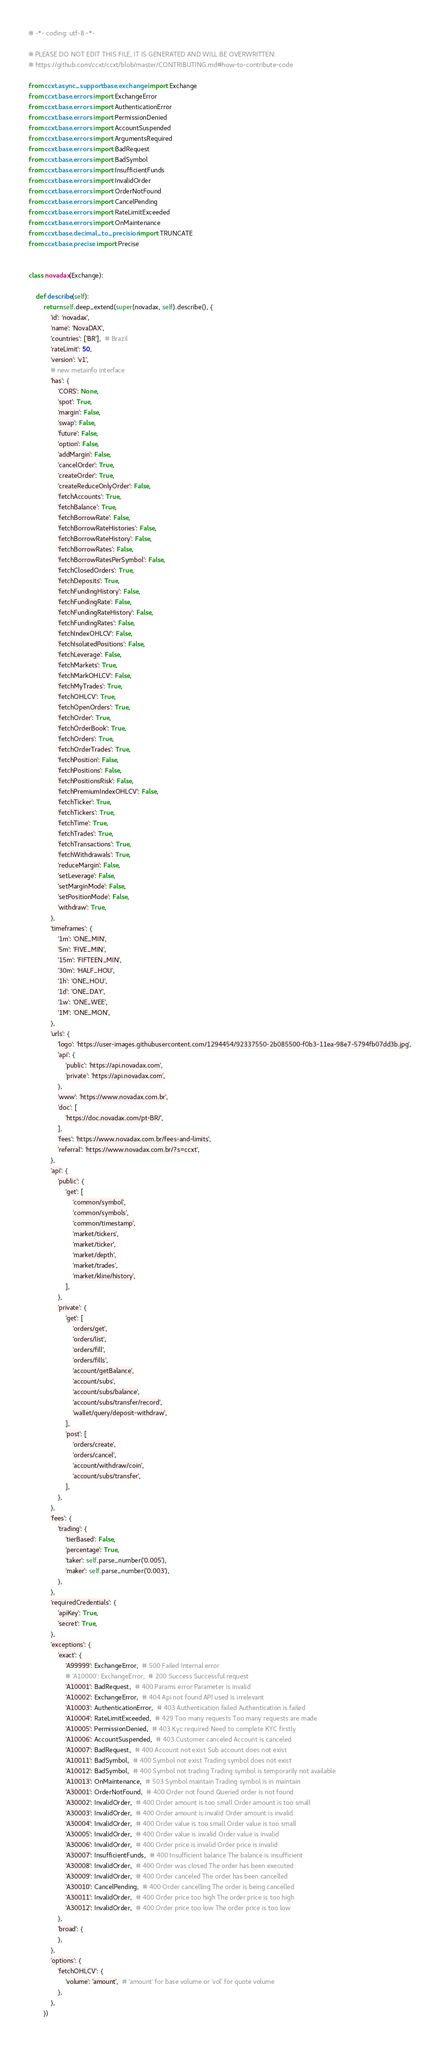Convert code to text. <code><loc_0><loc_0><loc_500><loc_500><_Python_># -*- coding: utf-8 -*-

# PLEASE DO NOT EDIT THIS FILE, IT IS GENERATED AND WILL BE OVERWRITTEN:
# https://github.com/ccxt/ccxt/blob/master/CONTRIBUTING.md#how-to-contribute-code

from ccxt.async_support.base.exchange import Exchange
from ccxt.base.errors import ExchangeError
from ccxt.base.errors import AuthenticationError
from ccxt.base.errors import PermissionDenied
from ccxt.base.errors import AccountSuspended
from ccxt.base.errors import ArgumentsRequired
from ccxt.base.errors import BadRequest
from ccxt.base.errors import BadSymbol
from ccxt.base.errors import InsufficientFunds
from ccxt.base.errors import InvalidOrder
from ccxt.base.errors import OrderNotFound
from ccxt.base.errors import CancelPending
from ccxt.base.errors import RateLimitExceeded
from ccxt.base.errors import OnMaintenance
from ccxt.base.decimal_to_precision import TRUNCATE
from ccxt.base.precise import Precise


class novadax(Exchange):

    def describe(self):
        return self.deep_extend(super(novadax, self).describe(), {
            'id': 'novadax',
            'name': 'NovaDAX',
            'countries': ['BR'],  # Brazil
            'rateLimit': 50,
            'version': 'v1',
            # new metainfo interface
            'has': {
                'CORS': None,
                'spot': True,
                'margin': False,
                'swap': False,
                'future': False,
                'option': False,
                'addMargin': False,
                'cancelOrder': True,
                'createOrder': True,
                'createReduceOnlyOrder': False,
                'fetchAccounts': True,
                'fetchBalance': True,
                'fetchBorrowRate': False,
                'fetchBorrowRateHistories': False,
                'fetchBorrowRateHistory': False,
                'fetchBorrowRates': False,
                'fetchBorrowRatesPerSymbol': False,
                'fetchClosedOrders': True,
                'fetchDeposits': True,
                'fetchFundingHistory': False,
                'fetchFundingRate': False,
                'fetchFundingRateHistory': False,
                'fetchFundingRates': False,
                'fetchIndexOHLCV': False,
                'fetchIsolatedPositions': False,
                'fetchLeverage': False,
                'fetchMarkets': True,
                'fetchMarkOHLCV': False,
                'fetchMyTrades': True,
                'fetchOHLCV': True,
                'fetchOpenOrders': True,
                'fetchOrder': True,
                'fetchOrderBook': True,
                'fetchOrders': True,
                'fetchOrderTrades': True,
                'fetchPosition': False,
                'fetchPositions': False,
                'fetchPositionsRisk': False,
                'fetchPremiumIndexOHLCV': False,
                'fetchTicker': True,
                'fetchTickers': True,
                'fetchTime': True,
                'fetchTrades': True,
                'fetchTransactions': True,
                'fetchWithdrawals': True,
                'reduceMargin': False,
                'setLeverage': False,
                'setMarginMode': False,
                'setPositionMode': False,
                'withdraw': True,
            },
            'timeframes': {
                '1m': 'ONE_MIN',
                '5m': 'FIVE_MIN',
                '15m': 'FIFTEEN_MIN',
                '30m': 'HALF_HOU',
                '1h': 'ONE_HOU',
                '1d': 'ONE_DAY',
                '1w': 'ONE_WEE',
                '1M': 'ONE_MON',
            },
            'urls': {
                'logo': 'https://user-images.githubusercontent.com/1294454/92337550-2b085500-f0b3-11ea-98e7-5794fb07dd3b.jpg',
                'api': {
                    'public': 'https://api.novadax.com',
                    'private': 'https://api.novadax.com',
                },
                'www': 'https://www.novadax.com.br',
                'doc': [
                    'https://doc.novadax.com/pt-BR/',
                ],
                'fees': 'https://www.novadax.com.br/fees-and-limits',
                'referral': 'https://www.novadax.com.br/?s=ccxt',
            },
            'api': {
                'public': {
                    'get': [
                        'common/symbol',
                        'common/symbols',
                        'common/timestamp',
                        'market/tickers',
                        'market/ticker',
                        'market/depth',
                        'market/trades',
                        'market/kline/history',
                    ],
                },
                'private': {
                    'get': [
                        'orders/get',
                        'orders/list',
                        'orders/fill',
                        'orders/fills',
                        'account/getBalance',
                        'account/subs',
                        'account/subs/balance',
                        'account/subs/transfer/record',
                        'wallet/query/deposit-withdraw',
                    ],
                    'post': [
                        'orders/create',
                        'orders/cancel',
                        'account/withdraw/coin',
                        'account/subs/transfer',
                    ],
                },
            },
            'fees': {
                'trading': {
                    'tierBased': False,
                    'percentage': True,
                    'taker': self.parse_number('0.005'),
                    'maker': self.parse_number('0.003'),
                },
            },
            'requiredCredentials': {
                'apiKey': True,
                'secret': True,
            },
            'exceptions': {
                'exact': {
                    'A99999': ExchangeError,  # 500 Failed Internal error
                    # 'A10000': ExchangeError,  # 200 Success Successful request
                    'A10001': BadRequest,  # 400 Params error Parameter is invalid
                    'A10002': ExchangeError,  # 404 Api not found API used is irrelevant
                    'A10003': AuthenticationError,  # 403 Authentication failed Authentication is failed
                    'A10004': RateLimitExceeded,  # 429 Too many requests Too many requests are made
                    'A10005': PermissionDenied,  # 403 Kyc required Need to complete KYC firstly
                    'A10006': AccountSuspended,  # 403 Customer canceled Account is canceled
                    'A10007': BadRequest,  # 400 Account not exist Sub account does not exist
                    'A10011': BadSymbol,  # 400 Symbol not exist Trading symbol does not exist
                    'A10012': BadSymbol,  # 400 Symbol not trading Trading symbol is temporarily not available
                    'A10013': OnMaintenance,  # 503 Symbol maintain Trading symbol is in maintain
                    'A30001': OrderNotFound,  # 400 Order not found Queried order is not found
                    'A30002': InvalidOrder,  # 400 Order amount is too small Order amount is too small
                    'A30003': InvalidOrder,  # 400 Order amount is invalid Order amount is invalid
                    'A30004': InvalidOrder,  # 400 Order value is too small Order value is too small
                    'A30005': InvalidOrder,  # 400 Order value is invalid Order value is invalid
                    'A30006': InvalidOrder,  # 400 Order price is invalid Order price is invalid
                    'A30007': InsufficientFunds,  # 400 Insufficient balance The balance is insufficient
                    'A30008': InvalidOrder,  # 400 Order was closed The order has been executed
                    'A30009': InvalidOrder,  # 400 Order canceled The order has been cancelled
                    'A30010': CancelPending,  # 400 Order cancelling The order is being cancelled
                    'A30011': InvalidOrder,  # 400 Order price too high The order price is too high
                    'A30012': InvalidOrder,  # 400 Order price too low The order price is too low
                },
                'broad': {
                },
            },
            'options': {
                'fetchOHLCV': {
                    'volume': 'amount',  # 'amount' for base volume or 'vol' for quote volume
                },
            },
        })
</code> 